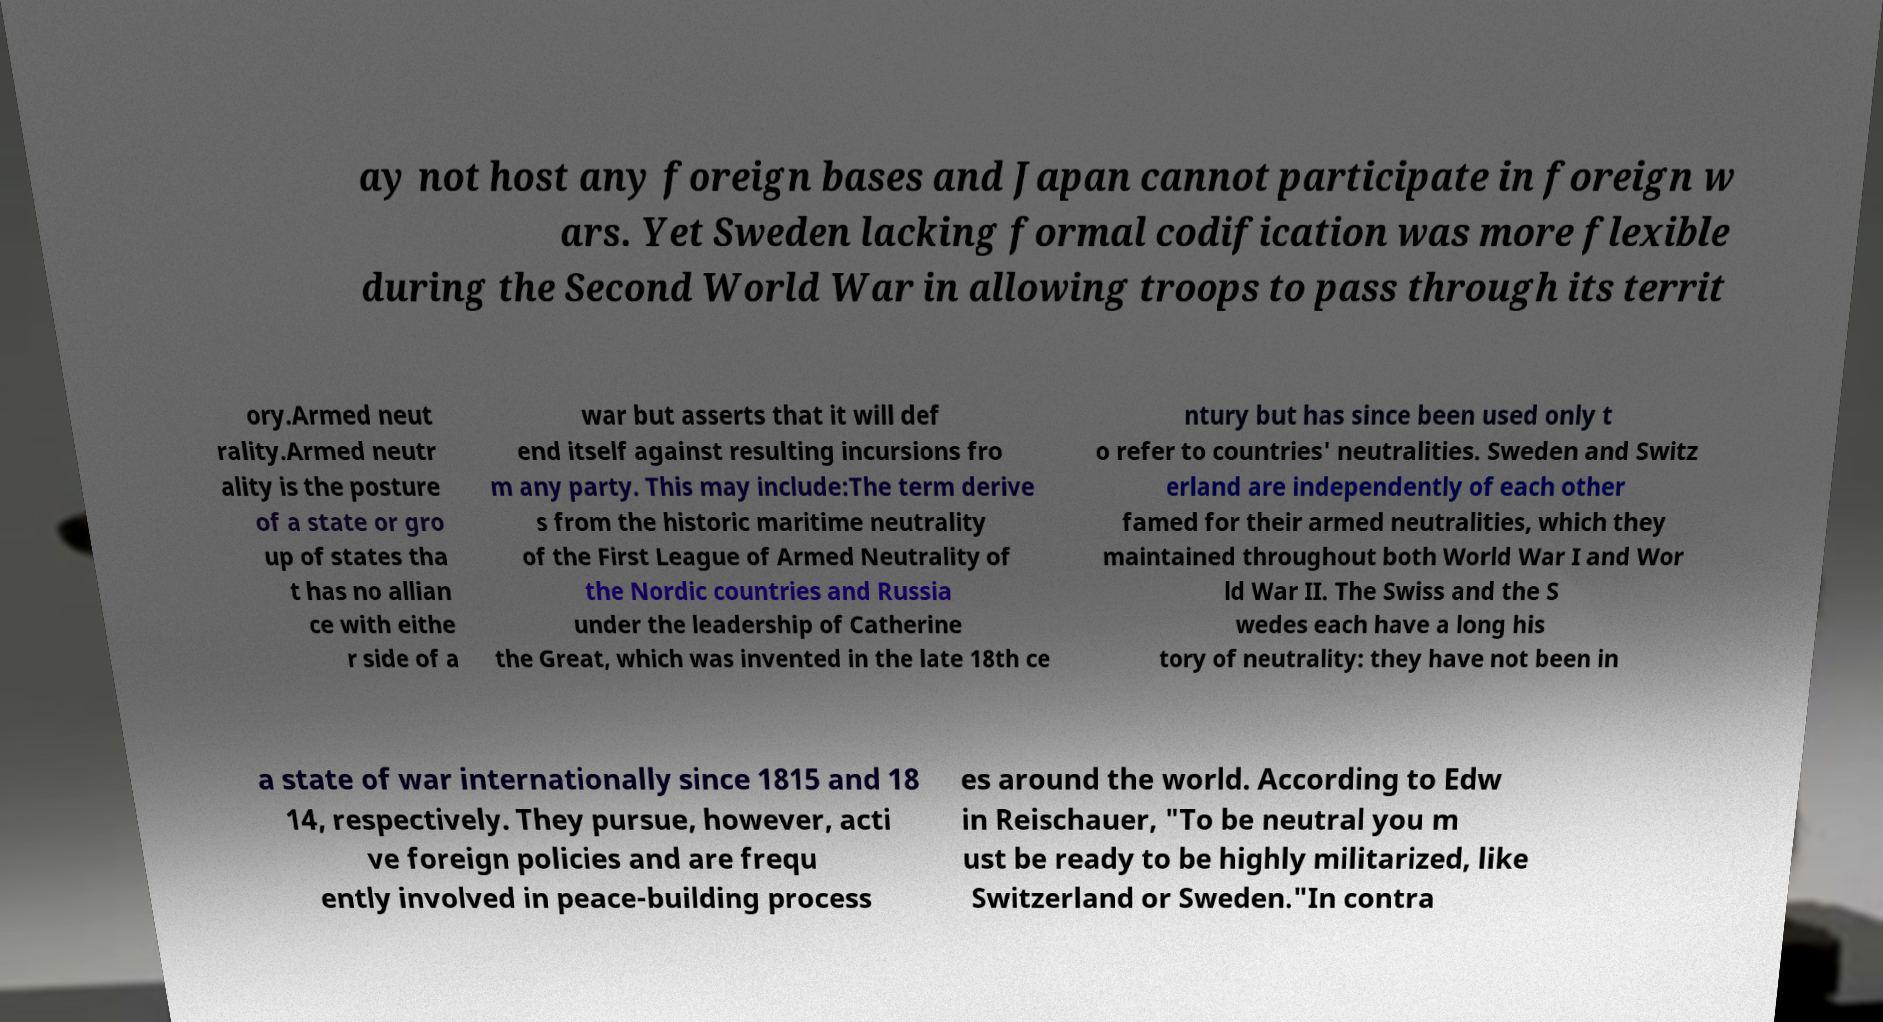There's text embedded in this image that I need extracted. Can you transcribe it verbatim? ay not host any foreign bases and Japan cannot participate in foreign w ars. Yet Sweden lacking formal codification was more flexible during the Second World War in allowing troops to pass through its territ ory.Armed neut rality.Armed neutr ality is the posture of a state or gro up of states tha t has no allian ce with eithe r side of a war but asserts that it will def end itself against resulting incursions fro m any party. This may include:The term derive s from the historic maritime neutrality of the First League of Armed Neutrality of the Nordic countries and Russia under the leadership of Catherine the Great, which was invented in the late 18th ce ntury but has since been used only t o refer to countries' neutralities. Sweden and Switz erland are independently of each other famed for their armed neutralities, which they maintained throughout both World War I and Wor ld War II. The Swiss and the S wedes each have a long his tory of neutrality: they have not been in a state of war internationally since 1815 and 18 14, respectively. They pursue, however, acti ve foreign policies and are frequ ently involved in peace-building process es around the world. According to Edw in Reischauer, "To be neutral you m ust be ready to be highly militarized, like Switzerland or Sweden."In contra 